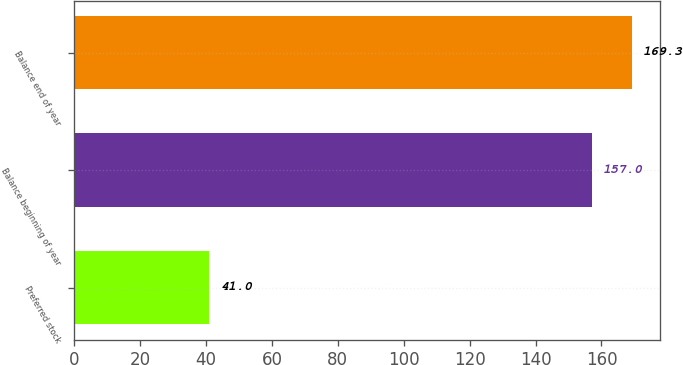Convert chart. <chart><loc_0><loc_0><loc_500><loc_500><bar_chart><fcel>Preferred stock<fcel>Balance beginning of year<fcel>Balance end of year<nl><fcel>41<fcel>157<fcel>169.3<nl></chart> 